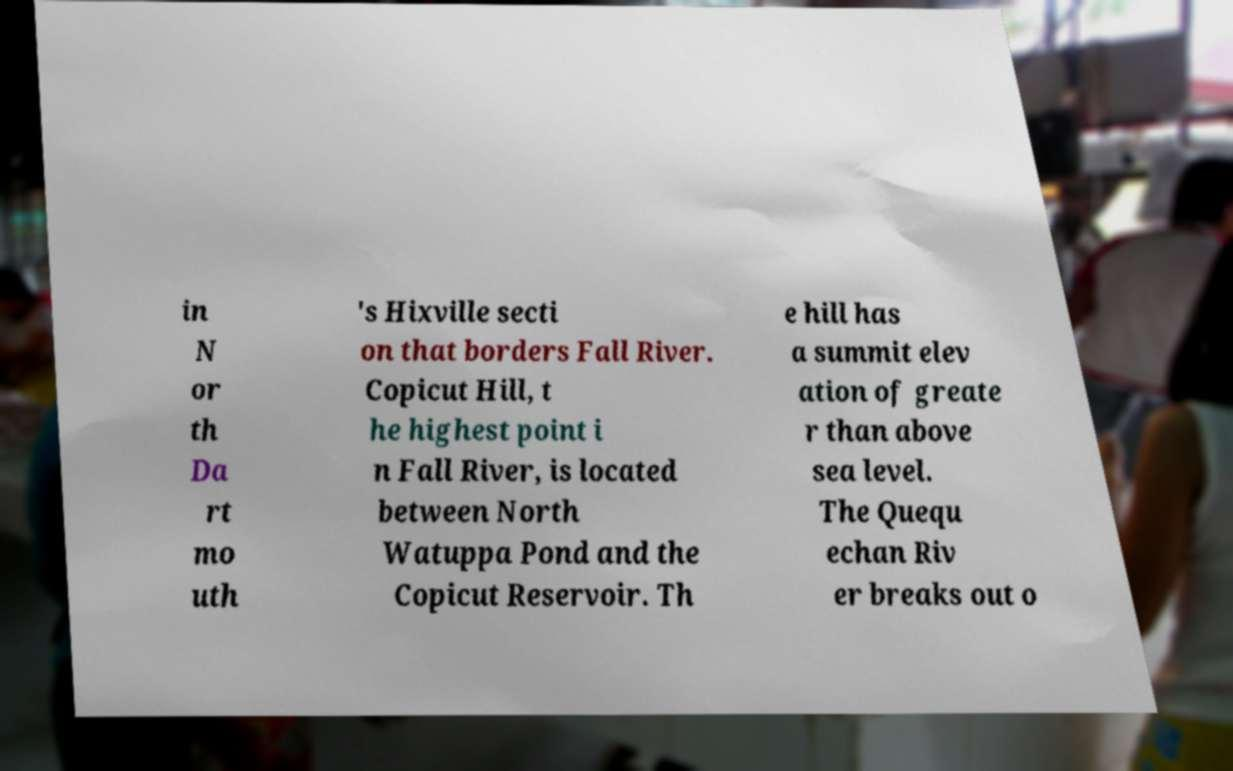What messages or text are displayed in this image? I need them in a readable, typed format. in N or th Da rt mo uth 's Hixville secti on that borders Fall River. Copicut Hill, t he highest point i n Fall River, is located between North Watuppa Pond and the Copicut Reservoir. Th e hill has a summit elev ation of greate r than above sea level. The Quequ echan Riv er breaks out o 